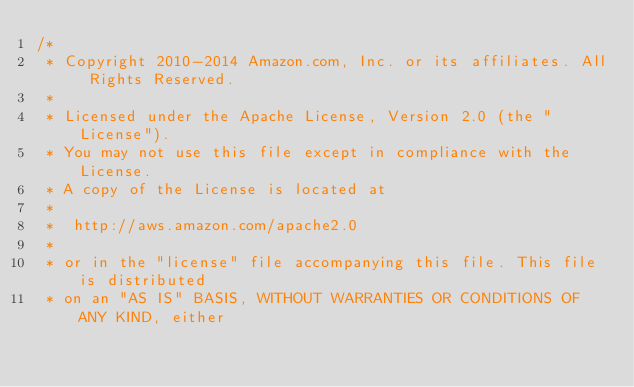Convert code to text. <code><loc_0><loc_0><loc_500><loc_500><_C#_>/*
 * Copyright 2010-2014 Amazon.com, Inc. or its affiliates. All Rights Reserved.
 * 
 * Licensed under the Apache License, Version 2.0 (the "License").
 * You may not use this file except in compliance with the License.
 * A copy of the License is located at
 * 
 *  http://aws.amazon.com/apache2.0
 * 
 * or in the "license" file accompanying this file. This file is distributed
 * on an "AS IS" BASIS, WITHOUT WARRANTIES OR CONDITIONS OF ANY KIND, either</code> 